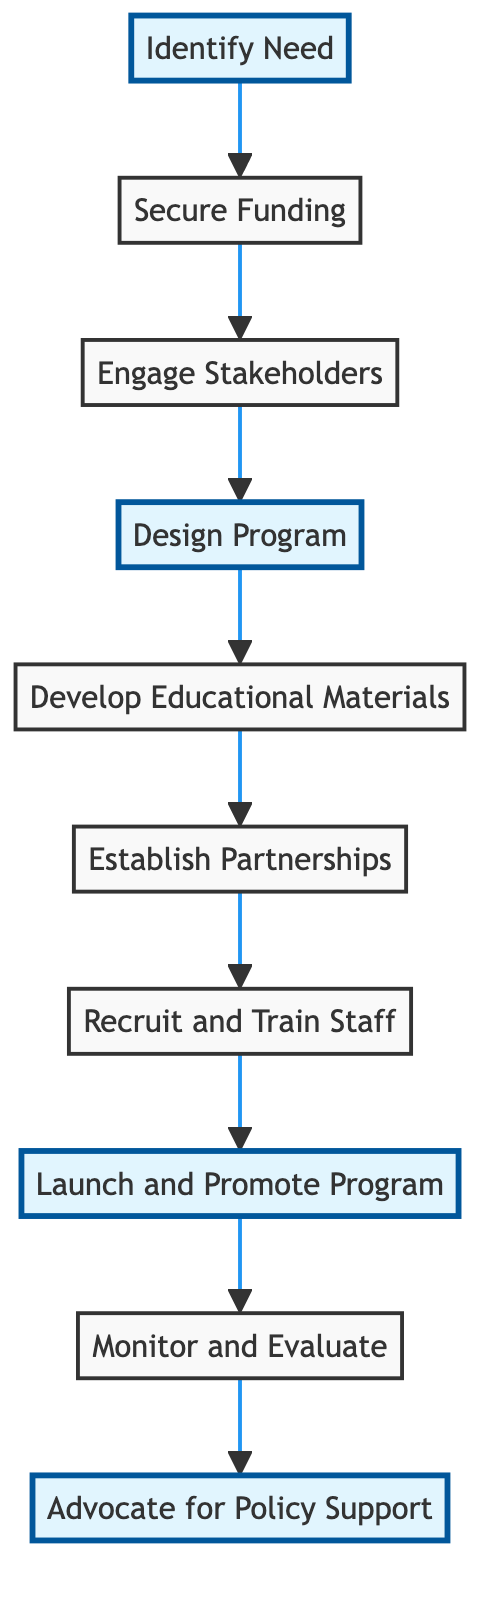What is the first step in the diagram? The first step is depicted at the top of the flowchart, labeled "Identify Need," which indicates that this is the initial action required to implement a Needle Exchange Program.
Answer: Identify Need How many total steps are shown in the diagram? By counting the steps listed from "Identify Need" to "Advocate for Policy Support," there are a total of ten defined steps in the flowchart.
Answer: 10 Which step comes immediately after "Secure Funding"? The diagram indicates that "Engage Stakeholders" is the step that follows "Secure Funding," forming a direct flow from one action to the next.
Answer: Engage Stakeholders What are the highlighted steps in the diagram? The highlighted steps include "Identify Need," "Design Program," "Launch and Promote Program," and "Advocate for Policy Support," which are emphasized to signify their importance in the overall process.
Answer: Identify Need, Design Program, Launch and Promote Program, Advocate for Policy Support What is the last step in the process illustrated? The flowchart's terminal node is "Advocate for Policy Support," indicating that this is the final action to be taken once all previous steps have been completed.
Answer: Advocate for Policy Support Which step involves working with local health authorities? "Engage Stakeholders" is the specific step where collaboration with local health authorities is emphasized, as it involves organizing meetings to discuss the program.
Answer: Engage Stakeholders What is the relationship between "Launch and Promote Program" and "Monitor and Evaluate"? The relationship is sequential; "Launch and Promote Program" is directly followed by "Monitor and Evaluate," indicating that evaluation is necessary after the program has been launched to assess its effectiveness.
Answer: Sequential What is the main goal of the "Develop Educational Materials" step? This step aims to create informational resources that educate users about safe injection practices and related health services, which is pivotal for the success of the program.
Answer: Educate users What type of partnerships are established in the "Establish Partnerships" step? The partnerships formed in this step include collaborations with local health clinics, NGOs, and community organizations aimed at providing comprehensive support services.
Answer: Collaborations with local health clinics, NGOs, and community organizations What is a critical factor to secure before proceeding to design the program? Securing funding is a critical prerequisite, as it enables the necessary resources to be available for the subsequent design and implementation of the Needle Exchange Program.
Answer: Secure Funding 